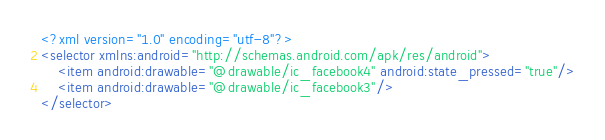<code> <loc_0><loc_0><loc_500><loc_500><_XML_><?xml version="1.0" encoding="utf-8"?>
<selector xmlns:android="http://schemas.android.com/apk/res/android">
    <item android:drawable="@drawable/ic_facebook4" android:state_pressed="true"/>
    <item android:drawable="@drawable/ic_facebook3"/>
</selector></code> 